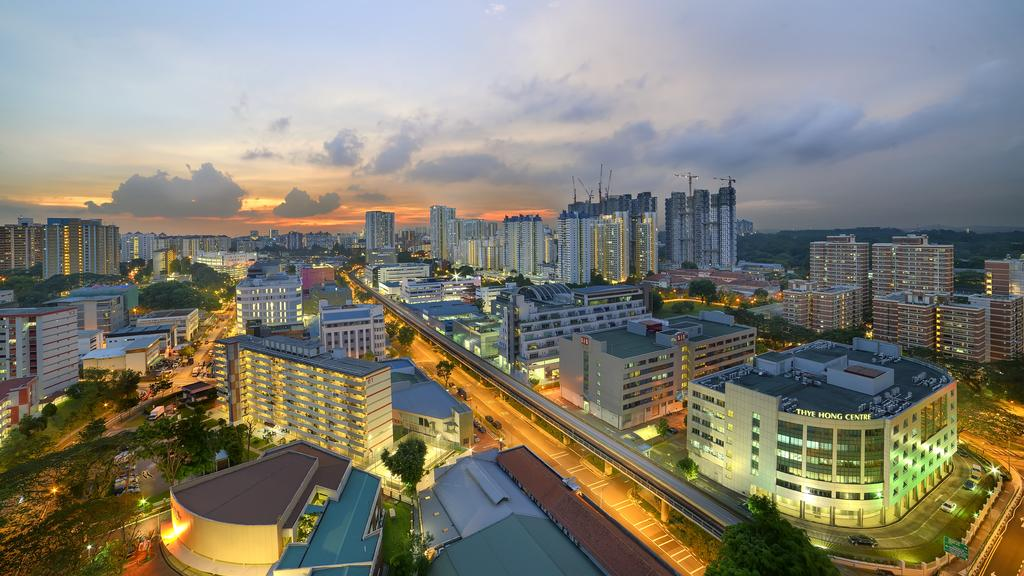What type of structures can be seen in the image? There are many buildings in the image. What is the purpose of the road in the image? The road in the image is likely for transportation. What type of vegetation is present in the image? There are trees in the image. What color is the crayon used to draw the buildings in the image? There is no crayon present in the image; the buildings are actual structures. Can you see a bat flying in the trees in the image? There is no bat visible in the image; only buildings, a road, and trees are present. 